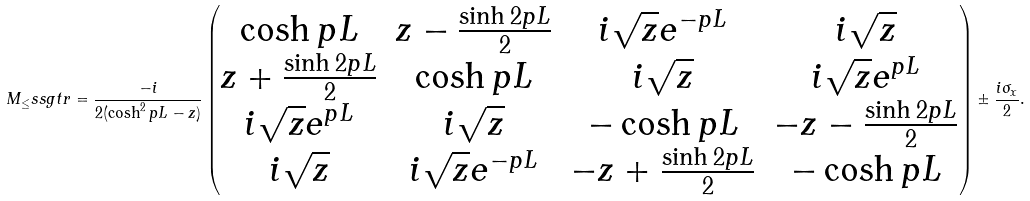<formula> <loc_0><loc_0><loc_500><loc_500>M _ { \leq } s s g t r = \frac { - i } { 2 ( \cosh ^ { 2 } p L - z ) } \begin{pmatrix} \cosh p L & z - \frac { \sinh 2 p L } { 2 } & i \sqrt { z } e ^ { - p L } & i \sqrt { z } \\ z + \frac { \sinh 2 p L } { 2 } & \cosh p L & i \sqrt { z } & i \sqrt { z } e ^ { p L } \\ i \sqrt { z } e ^ { p L } & i \sqrt { z } & - \cosh p L & - z - \frac { \sinh 2 p L } { 2 } \\ i \sqrt { z } & i \sqrt { z } e ^ { - p L } & - z + \frac { \sinh 2 p L } { 2 } & - \cosh p L \end{pmatrix} \pm \frac { i \sigma _ { x } } { 2 } .</formula> 